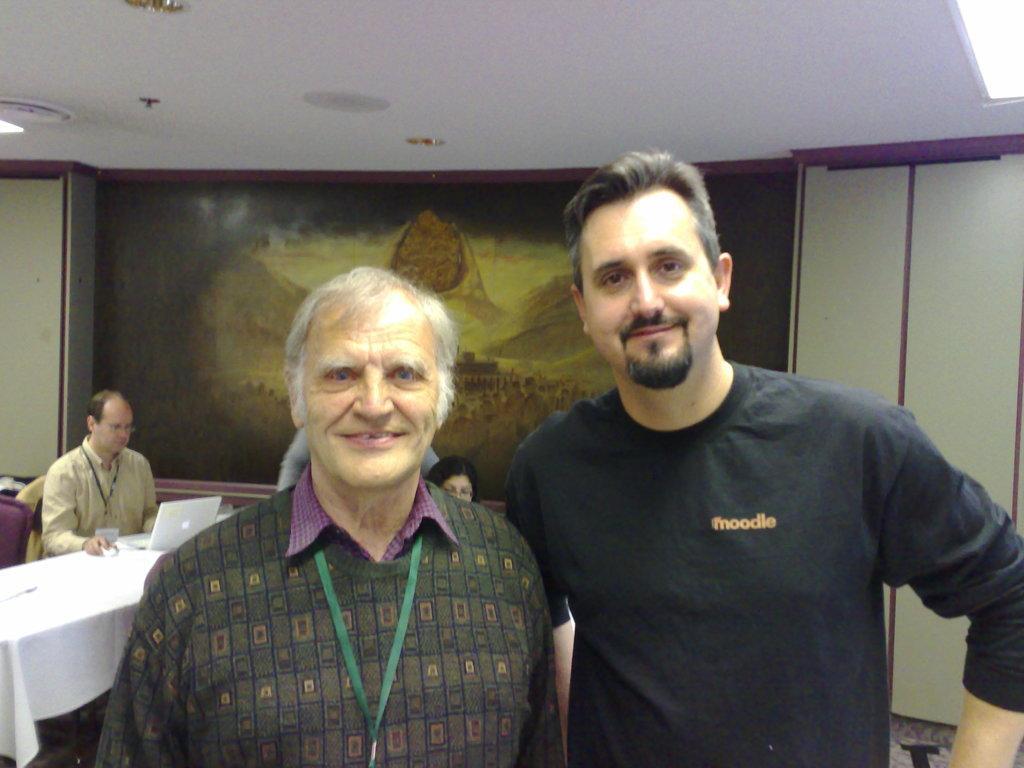In one or two sentences, can you explain what this image depicts? There are two persons in this image looking at the camera and at the background of the image there is a scenery. 